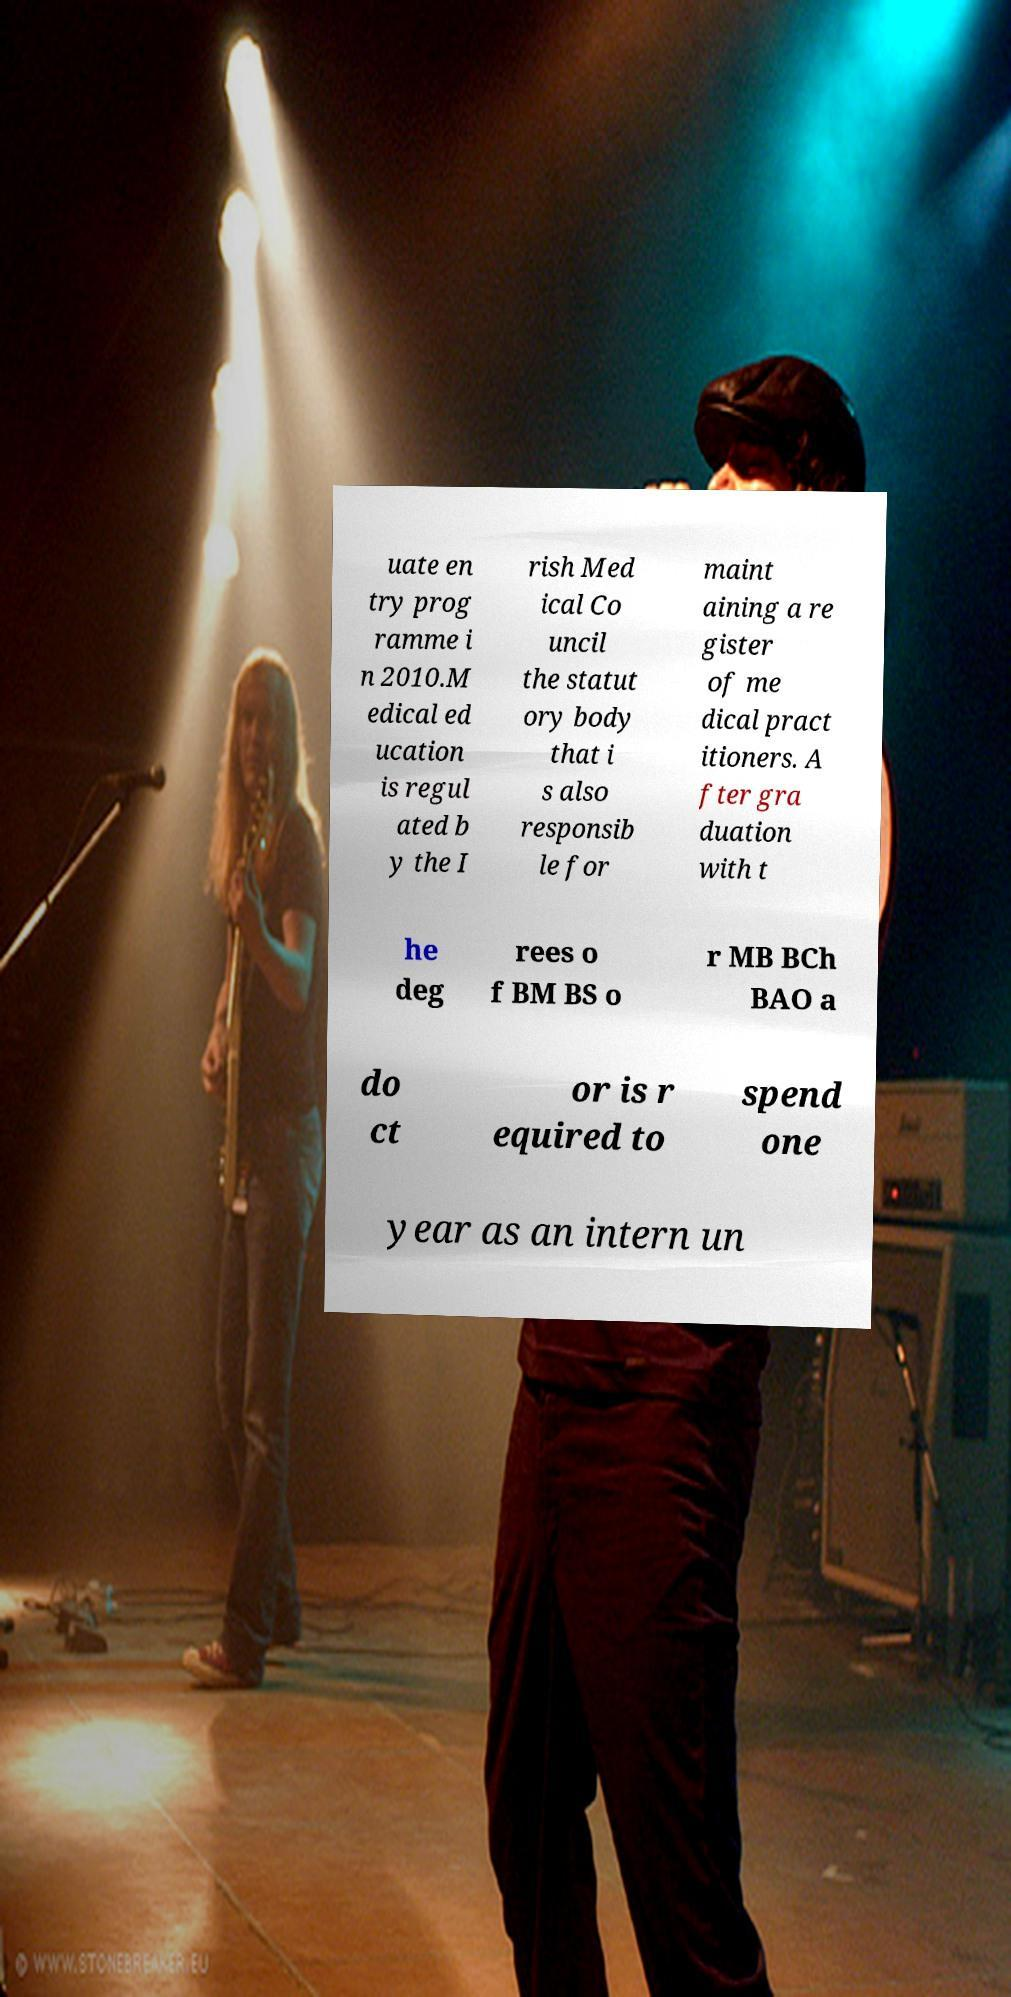There's text embedded in this image that I need extracted. Can you transcribe it verbatim? uate en try prog ramme i n 2010.M edical ed ucation is regul ated b y the I rish Med ical Co uncil the statut ory body that i s also responsib le for maint aining a re gister of me dical pract itioners. A fter gra duation with t he deg rees o f BM BS o r MB BCh BAO a do ct or is r equired to spend one year as an intern un 